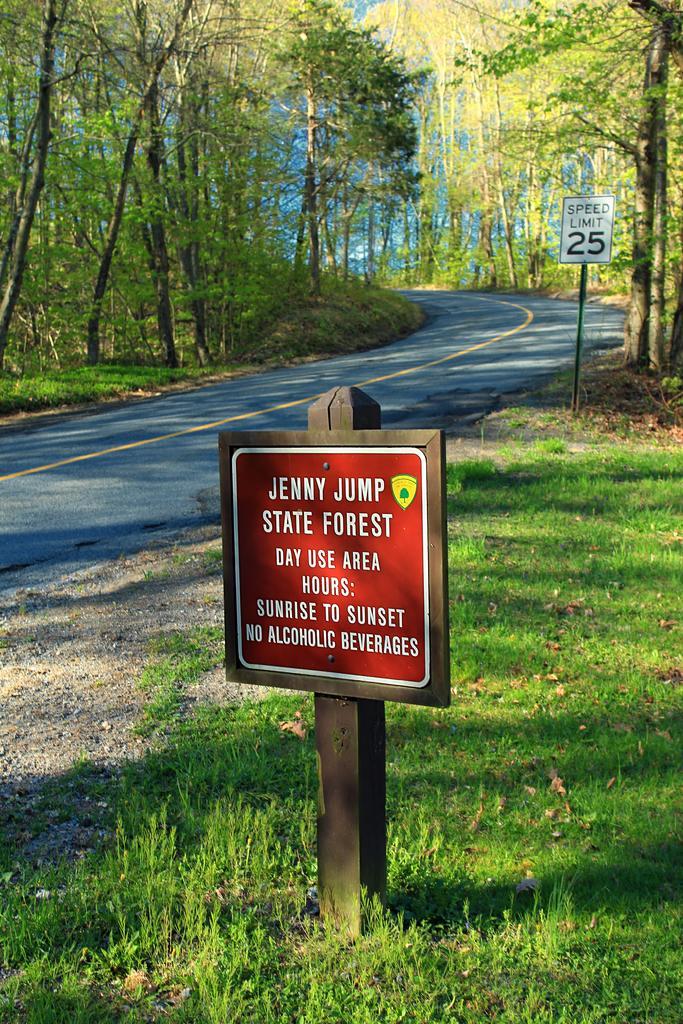Describe this image in one or two sentences. In this image we can see the sign boards with some text on them. We can also see some grass, the road and a group of trees. 